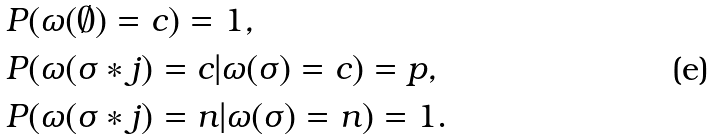<formula> <loc_0><loc_0><loc_500><loc_500>& P ( \omega ( \emptyset ) = c ) = 1 , \\ & P ( \omega ( \sigma * j ) = c | \omega ( \sigma ) = c ) = p , \\ & P ( \omega ( \sigma * j ) = n | \omega ( \sigma ) = n ) = 1 .</formula> 